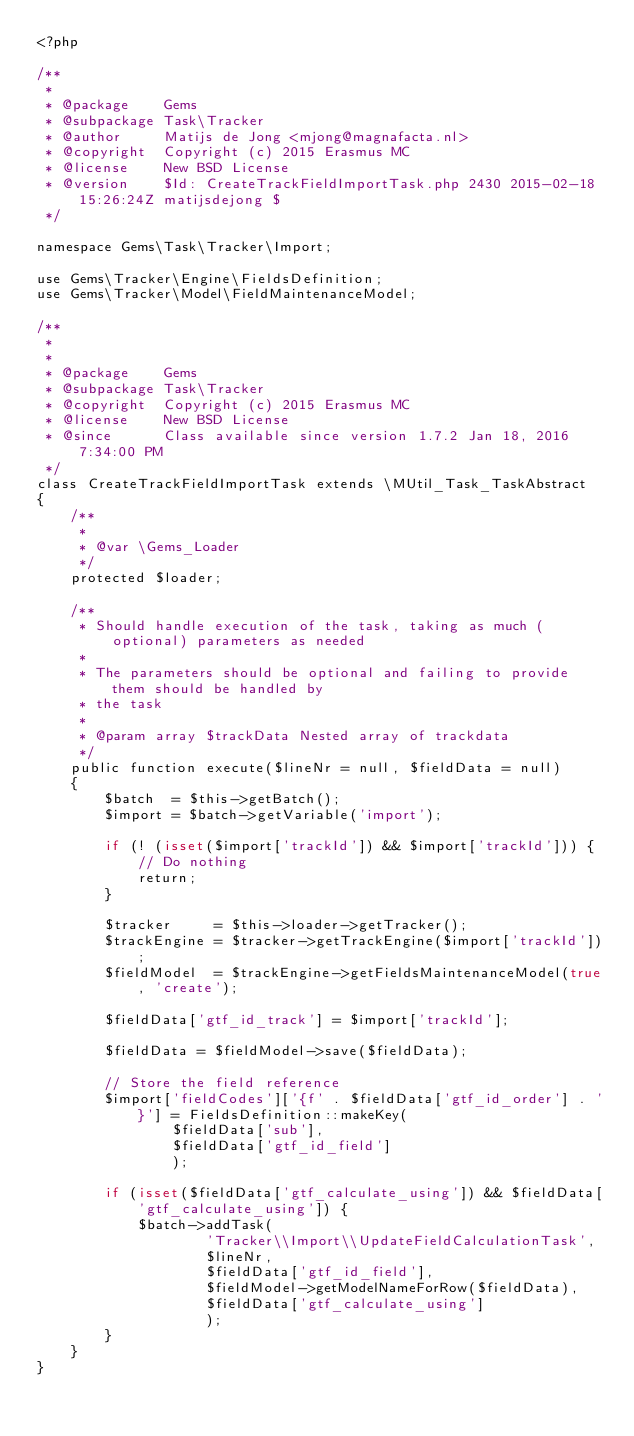Convert code to text. <code><loc_0><loc_0><loc_500><loc_500><_PHP_><?php

/**
 *
 * @package    Gems
 * @subpackage Task\Tracker
 * @author     Matijs de Jong <mjong@magnafacta.nl>
 * @copyright  Copyright (c) 2015 Erasmus MC
 * @license    New BSD License
 * @version    $Id: CreateTrackFieldImportTask.php 2430 2015-02-18 15:26:24Z matijsdejong $
 */

namespace Gems\Task\Tracker\Import;

use Gems\Tracker\Engine\FieldsDefinition;
use Gems\Tracker\Model\FieldMaintenanceModel;

/**
 *
 *
 * @package    Gems
 * @subpackage Task\Tracker
 * @copyright  Copyright (c) 2015 Erasmus MC
 * @license    New BSD License
 * @since      Class available since version 1.7.2 Jan 18, 2016 7:34:00 PM
 */
class CreateTrackFieldImportTask extends \MUtil_Task_TaskAbstract
{
    /**
     *
     * @var \Gems_Loader
     */
    protected $loader;

    /**
     * Should handle execution of the task, taking as much (optional) parameters as needed
     *
     * The parameters should be optional and failing to provide them should be handled by
     * the task
     *
     * @param array $trackData Nested array of trackdata
     */
    public function execute($lineNr = null, $fieldData = null)
    {
        $batch  = $this->getBatch();
        $import = $batch->getVariable('import');

        if (! (isset($import['trackId']) && $import['trackId'])) {
            // Do nothing
            return;
        }

        $tracker     = $this->loader->getTracker();
        $trackEngine = $tracker->getTrackEngine($import['trackId']);
        $fieldModel  = $trackEngine->getFieldsMaintenanceModel(true, 'create');

        $fieldData['gtf_id_track'] = $import['trackId'];

        $fieldData = $fieldModel->save($fieldData);

        // Store the field reference
        $import['fieldCodes']['{f' . $fieldData['gtf_id_order'] . '}'] = FieldsDefinition::makeKey(
                $fieldData['sub'],
                $fieldData['gtf_id_field']
                );

        if (isset($fieldData['gtf_calculate_using']) && $fieldData['gtf_calculate_using']) {
            $batch->addTask(
                    'Tracker\\Import\\UpdateFieldCalculationTask',
                    $lineNr,
                    $fieldData['gtf_id_field'],
                    $fieldModel->getModelNameForRow($fieldData),
                    $fieldData['gtf_calculate_using']
                    );
        }
    }
}
</code> 